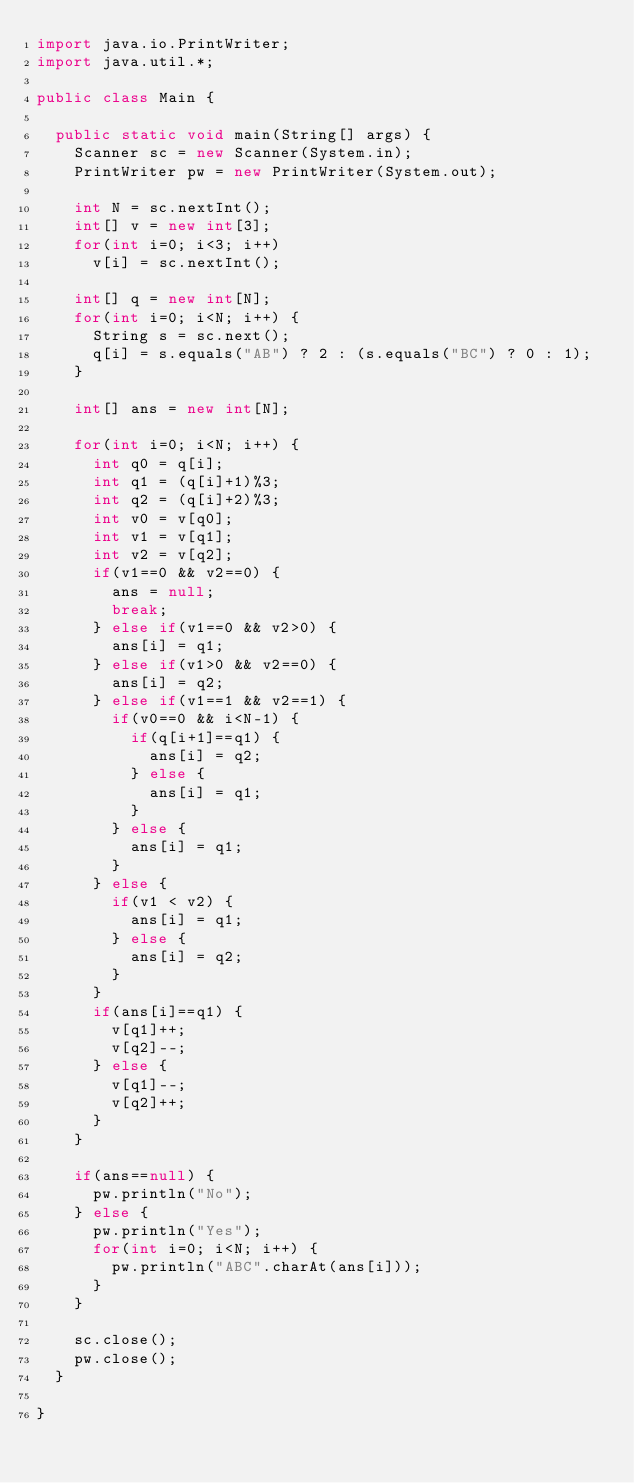Convert code to text. <code><loc_0><loc_0><loc_500><loc_500><_Java_>import java.io.PrintWriter;
import java.util.*;

public class Main {
	
	public static void main(String[] args) {
		Scanner sc = new Scanner(System.in);
		PrintWriter pw = new PrintWriter(System.out);
		
		int N = sc.nextInt();
		int[] v = new int[3];
		for(int i=0; i<3; i++)
			v[i] = sc.nextInt();
		
		int[] q = new int[N];
		for(int i=0; i<N; i++) {
			String s = sc.next();
			q[i] = s.equals("AB") ? 2 : (s.equals("BC") ? 0 : 1);
		}

		int[] ans = new int[N];

		for(int i=0; i<N; i++) {
			int q0 = q[i];
			int q1 = (q[i]+1)%3;
			int q2 = (q[i]+2)%3;
			int v0 = v[q0];
			int v1 = v[q1];
			int v2 = v[q2];
			if(v1==0 && v2==0) {
				ans = null;
				break;
			} else if(v1==0 && v2>0) {
				ans[i] = q1;
			} else if(v1>0 && v2==0) {
				ans[i] = q2;
			} else if(v1==1 && v2==1) {
				if(v0==0 && i<N-1) {
					if(q[i+1]==q1) {
						ans[i] = q2;
					} else {
						ans[i] = q1;
					}
				} else {
					ans[i] = q1;
				}
			} else {
				if(v1 < v2) {
					ans[i] = q1;
				} else {
					ans[i] = q2;
				}
			}
			if(ans[i]==q1) {
				v[q1]++;
				v[q2]--;
			} else {
				v[q1]--;
				v[q2]++;
			}
		}

		if(ans==null) {
			pw.println("No");
		} else {
			pw.println("Yes");
			for(int i=0; i<N; i++) {
				pw.println("ABC".charAt(ans[i]));
			}
		}
		
		sc.close();
		pw.close();
	}

}
</code> 